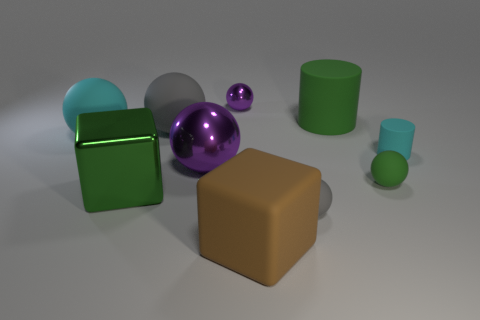There is a big thing that is the same color as the large metallic cube; what is it made of?
Provide a short and direct response. Rubber. There is a green object left of the big rubber cylinder; what is its material?
Provide a short and direct response. Metal. Is the tiny thing behind the big cyan matte object made of the same material as the large purple ball?
Provide a short and direct response. Yes. What number of things are large metallic objects or big matte objects that are in front of the green sphere?
Offer a terse response. 3. The cyan thing that is the same shape as the small green object is what size?
Make the answer very short. Large. Are there any large cyan spheres behind the green cylinder?
Give a very brief answer. No. Is the color of the cylinder that is behind the large gray matte object the same as the matte sphere that is right of the green cylinder?
Give a very brief answer. Yes. Are there any big metallic things of the same shape as the brown matte thing?
Offer a terse response. Yes. What number of other things are the same color as the tiny matte cylinder?
Your answer should be very brief. 1. There is a metal sphere in front of the big green object to the right of the gray object left of the rubber cube; what color is it?
Offer a very short reply. Purple. 